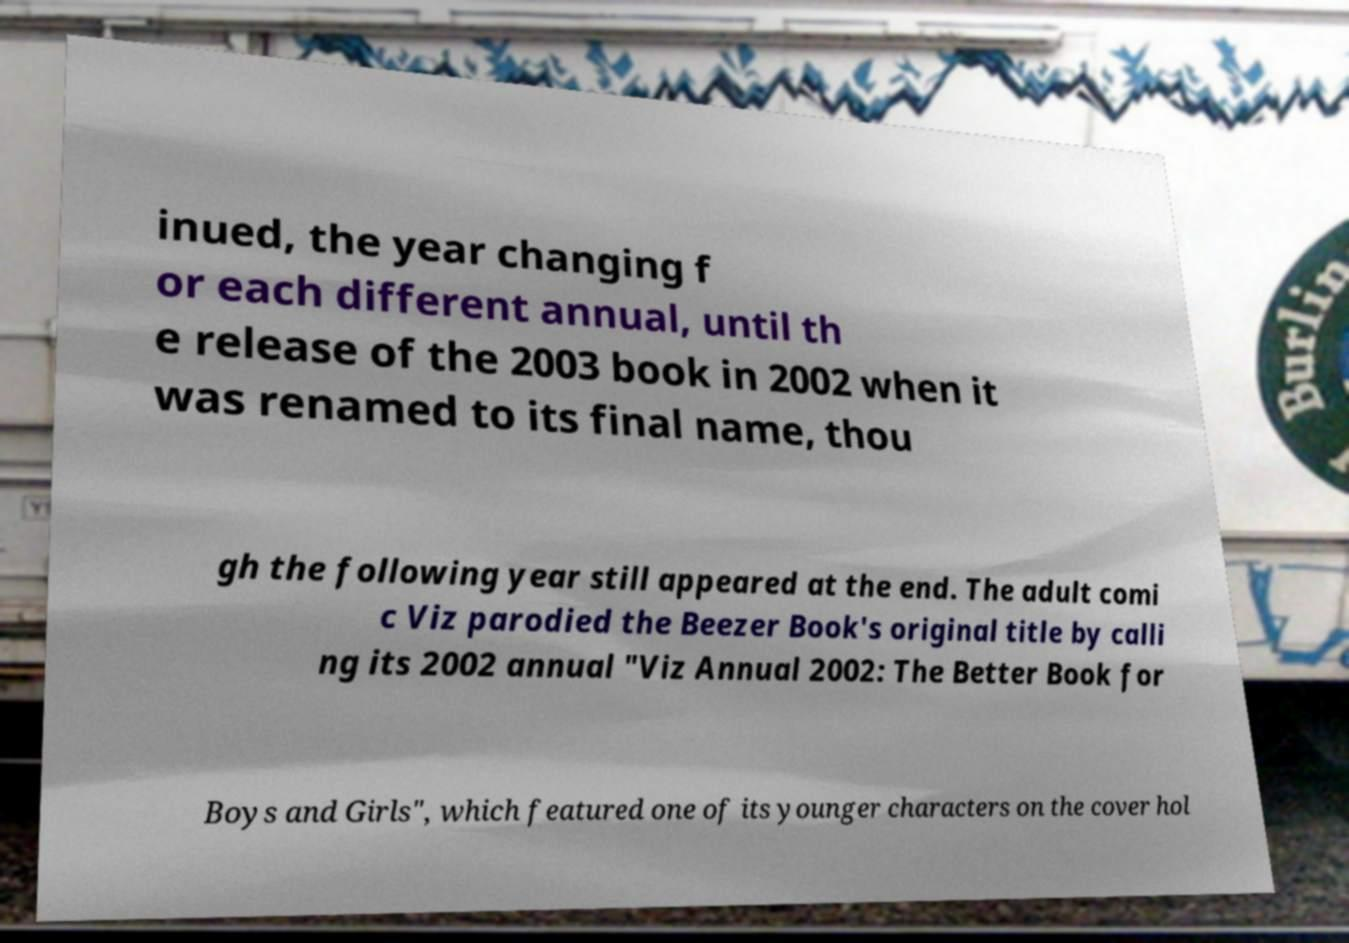For documentation purposes, I need the text within this image transcribed. Could you provide that? inued, the year changing f or each different annual, until th e release of the 2003 book in 2002 when it was renamed to its final name, thou gh the following year still appeared at the end. The adult comi c Viz parodied the Beezer Book's original title by calli ng its 2002 annual "Viz Annual 2002: The Better Book for Boys and Girls", which featured one of its younger characters on the cover hol 